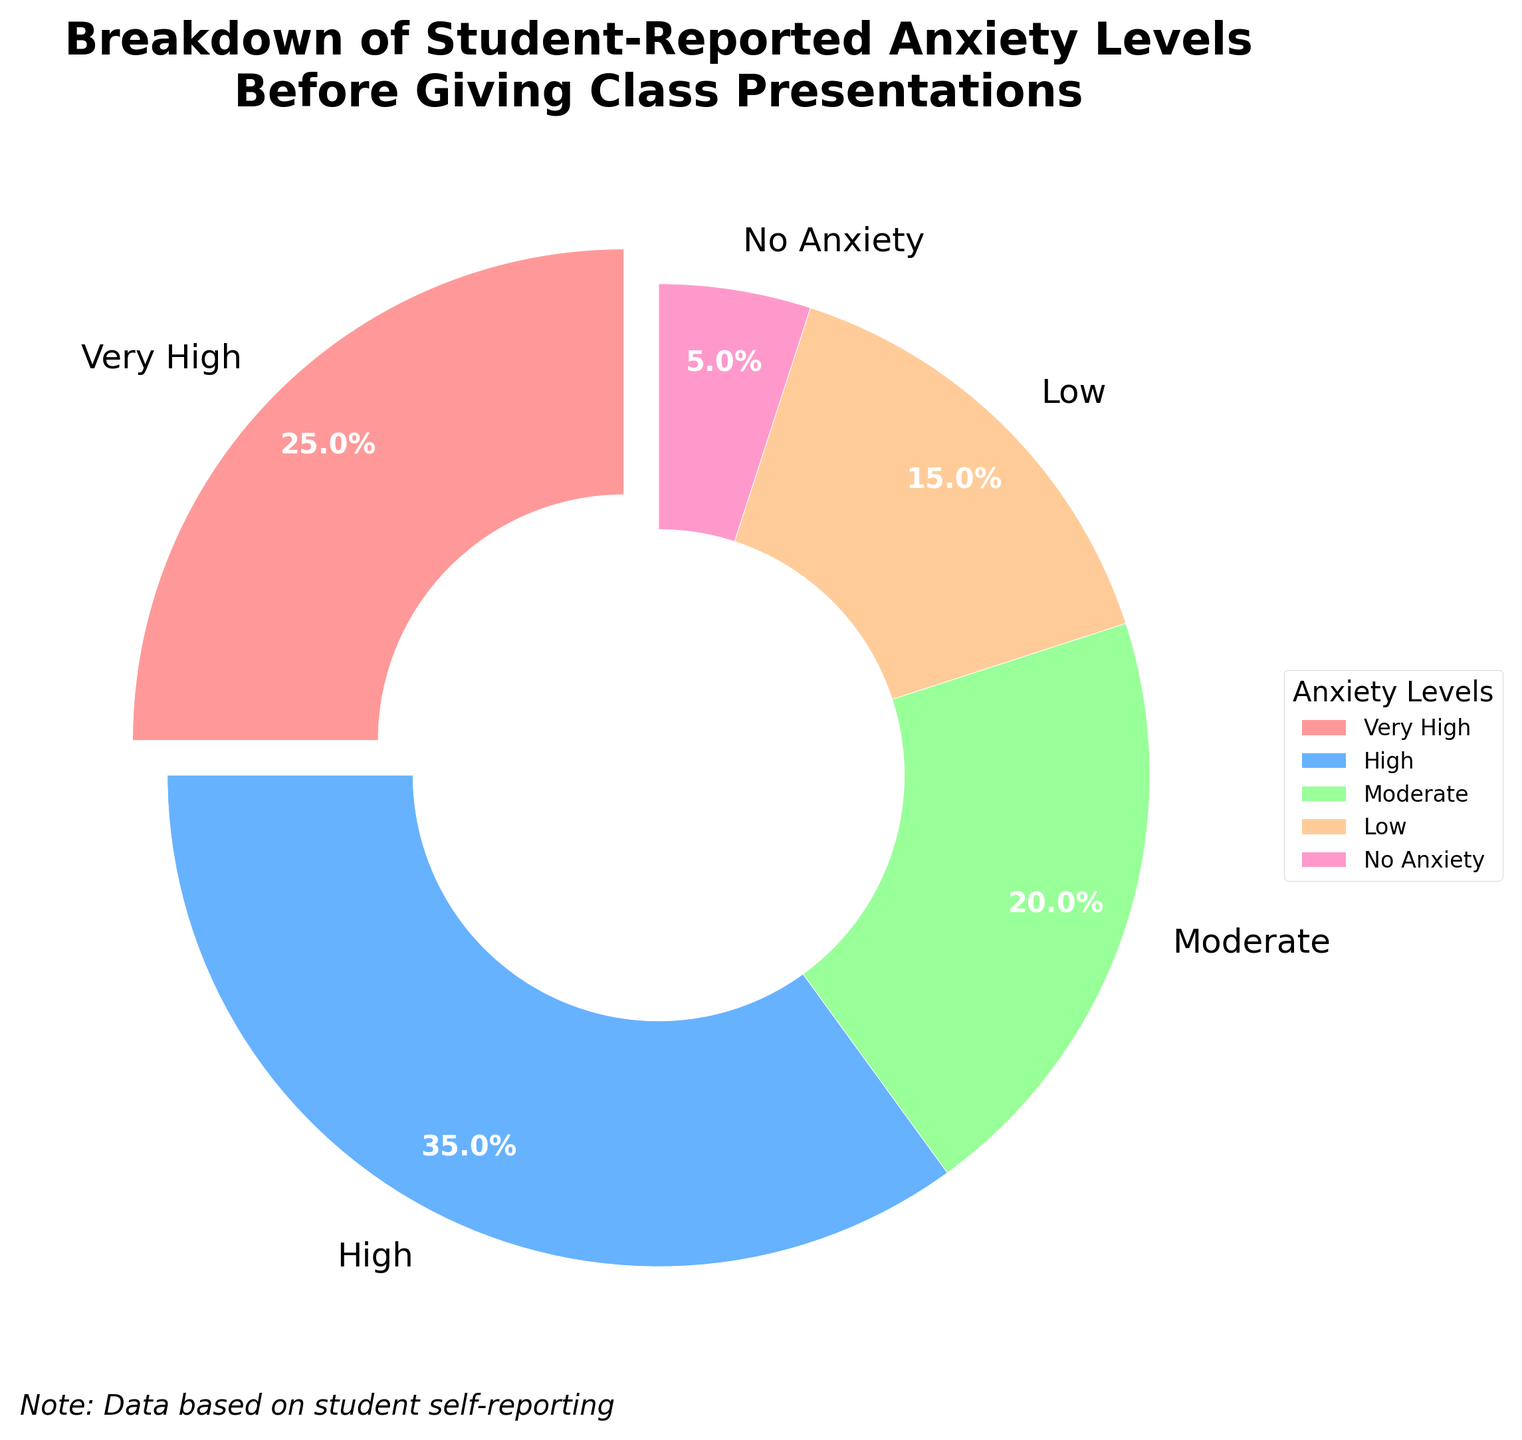Which anxiety level is reported the most by students? The largest wedge in the pie chart represents the highest percentage, which is labeled as 35% and corresponds to the "High" anxiety level.
Answer: High Which anxiety level is represented by the smallest percentage? The smallest wedge in the pie chart represents the lowest percentage, which is labeled as 5% and corresponds to the "No Anxiety" level.
Answer: No Anxiety How much more common is the "High" anxiety level compared to the "Low" anxiety level? The "High" anxiety level is represented by 35%, and the "Low" anxiety level is represented by 15%. To find the difference, subtract 15 from 35: 35% - 15% = 20%.
Answer: 20% What is the combined percentage of students reporting "Very High" and "Moderate" anxiety levels? The "Very High" anxiety level is 25%, and the "Moderate" anxiety level is 20%. Adding these together gives 25% + 20% = 45%.
Answer: 45% What percentage of students report experiencing low anxiety levels or none at all? The "Low" anxiety level is 15%, and the "No Anxiety" level is 5%. Adding these together gives 15% + 5% = 20%.
Answer: 20% Which anxiety levels have close proportions and what are their percentages? The "Moderate" anxiety level (20%) and "Low" anxiety level (15%) are closest in proportion.
Answer: Moderate: 20%, Low: 15% What is the visual highlight of the "Very High" anxiety level in the pie chart? The "Very High" anxiety level slice is visually highlighted by being slightly separated from the rest of the pie chart.
Answer: Slightly separated from the rest What is the difference in percentage between students reporting "High" anxiety levels and those reporting "Moderate" anxiety levels? The "High" anxiety level percentage is 35%, and the "Moderate" anxiety level percentage is 20%. To find the difference, subtract 20 from 35: 35% - 20% = 15%.
Answer: 15% Does the combined percentage of "Moderate" and "Low" anxiety levels exceed the percentage of the "High" anxiety level? The "Moderate" anxiety level is 20%, and the "Low" anxiety level is 15%. Adding these together gives 20% + 15% = 35%, which is equal to the "High" anxiety level at 35%.
Answer: No (They are equal) 